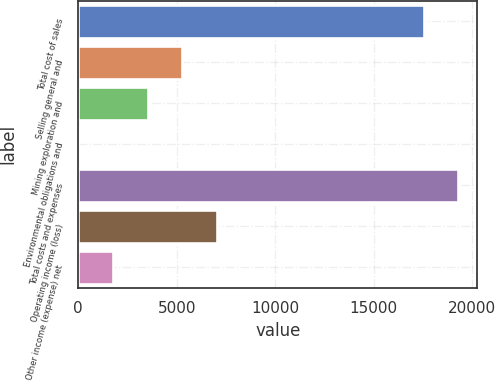Convert chart to OTSL. <chart><loc_0><loc_0><loc_500><loc_500><bar_chart><fcel>Total cost of sales<fcel>Selling general and<fcel>Mining exploration and<fcel>Environmental obligations and<fcel>Total costs and expenses<fcel>Operating income (loss)<fcel>Other income (expense) net<nl><fcel>17534<fcel>5277.5<fcel>3523<fcel>14<fcel>19288.5<fcel>7032<fcel>1768.5<nl></chart> 